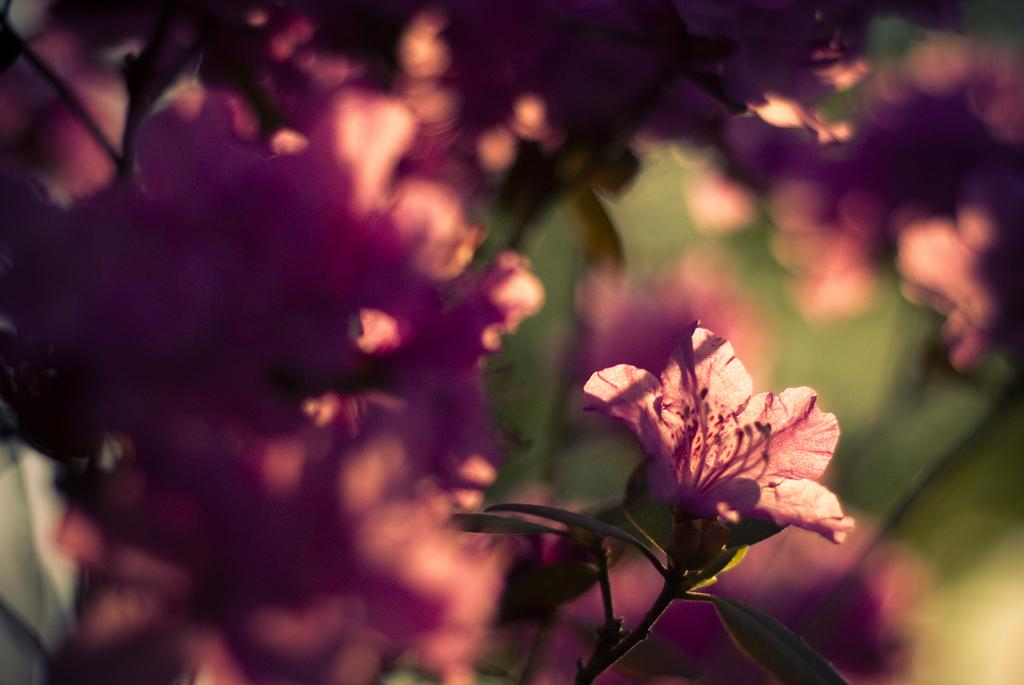What color are the flowers in the image? The flowers in the image are pink. What type of plant do the flowers belong to? The flowers belong to a plant. Can you describe the surroundings in the image? The surroundings of the image are blurred. Is there a giraffe visible in the image? No, there is no giraffe present in the image. What type of connection can be seen between the flowers and the plant? The flowers are part of the plant, so there is a natural connection between them, but the image does not show any specific connection. 